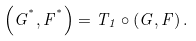Convert formula to latex. <formula><loc_0><loc_0><loc_500><loc_500>\left ( G ^ { ^ { * } } , F ^ { ^ { * } } \right ) = T _ { 1 } \circ \left ( G , F \right ) .</formula> 